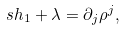<formula> <loc_0><loc_0><loc_500><loc_500>s h _ { 1 } + \lambda = \partial _ { j } \rho ^ { j } ,</formula> 